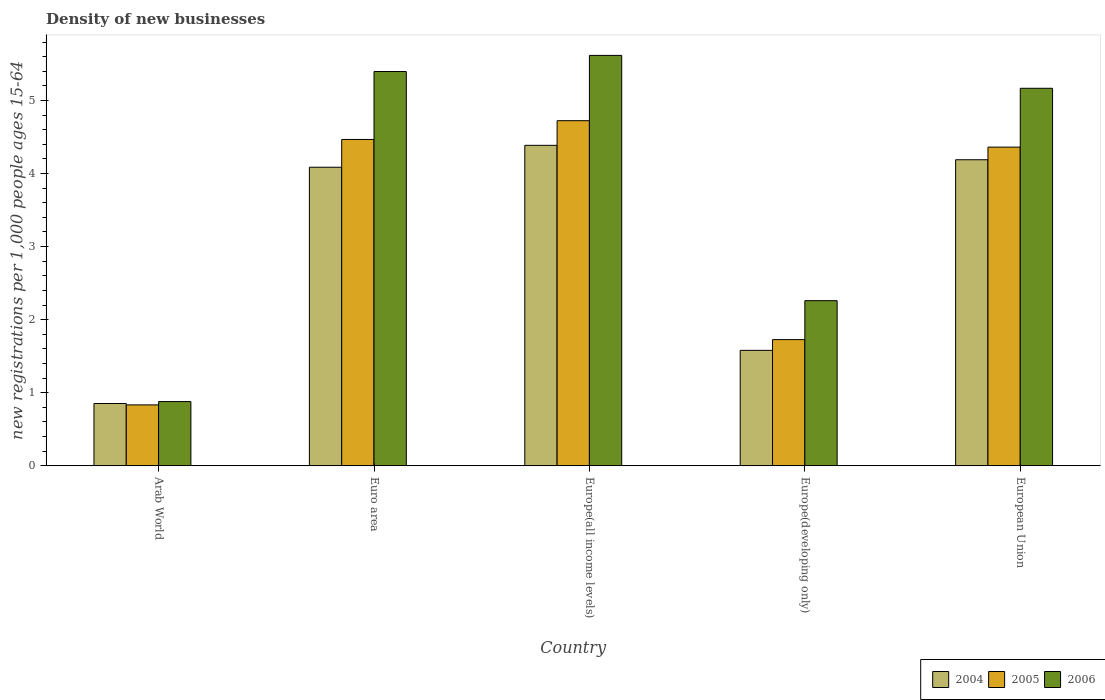How many different coloured bars are there?
Give a very brief answer. 3. Are the number of bars per tick equal to the number of legend labels?
Keep it short and to the point. Yes. How many bars are there on the 3rd tick from the right?
Keep it short and to the point. 3. What is the label of the 4th group of bars from the left?
Make the answer very short. Europe(developing only). In how many cases, is the number of bars for a given country not equal to the number of legend labels?
Offer a very short reply. 0. What is the number of new registrations in 2004 in Europe(developing only)?
Provide a succinct answer. 1.58. Across all countries, what is the maximum number of new registrations in 2006?
Keep it short and to the point. 5.62. Across all countries, what is the minimum number of new registrations in 2005?
Provide a succinct answer. 0.83. In which country was the number of new registrations in 2004 maximum?
Your answer should be very brief. Europe(all income levels). In which country was the number of new registrations in 2004 minimum?
Your answer should be compact. Arab World. What is the total number of new registrations in 2005 in the graph?
Give a very brief answer. 16.11. What is the difference between the number of new registrations in 2005 in Europe(all income levels) and that in Europe(developing only)?
Provide a succinct answer. 3. What is the difference between the number of new registrations in 2005 in Arab World and the number of new registrations in 2004 in Euro area?
Make the answer very short. -3.25. What is the average number of new registrations in 2004 per country?
Offer a terse response. 3.02. What is the difference between the number of new registrations of/in 2006 and number of new registrations of/in 2005 in European Union?
Your response must be concise. 0.81. What is the ratio of the number of new registrations in 2004 in Arab World to that in Europe(all income levels)?
Your response must be concise. 0.19. Is the difference between the number of new registrations in 2006 in Arab World and European Union greater than the difference between the number of new registrations in 2005 in Arab World and European Union?
Give a very brief answer. No. What is the difference between the highest and the second highest number of new registrations in 2006?
Your answer should be very brief. -0.22. What is the difference between the highest and the lowest number of new registrations in 2004?
Give a very brief answer. 3.53. Is the sum of the number of new registrations in 2005 in Arab World and Euro area greater than the maximum number of new registrations in 2006 across all countries?
Your answer should be compact. No. What does the 3rd bar from the right in Euro area represents?
Provide a short and direct response. 2004. Is it the case that in every country, the sum of the number of new registrations in 2004 and number of new registrations in 2005 is greater than the number of new registrations in 2006?
Provide a succinct answer. Yes. How many countries are there in the graph?
Offer a very short reply. 5. What is the difference between two consecutive major ticks on the Y-axis?
Provide a succinct answer. 1. Are the values on the major ticks of Y-axis written in scientific E-notation?
Provide a short and direct response. No. Does the graph contain grids?
Give a very brief answer. No. How many legend labels are there?
Your response must be concise. 3. What is the title of the graph?
Give a very brief answer. Density of new businesses. What is the label or title of the X-axis?
Your answer should be very brief. Country. What is the label or title of the Y-axis?
Ensure brevity in your answer.  New registrations per 1,0 people ages 15-64. What is the new registrations per 1,000 people ages 15-64 of 2004 in Arab World?
Make the answer very short. 0.85. What is the new registrations per 1,000 people ages 15-64 of 2005 in Arab World?
Your response must be concise. 0.83. What is the new registrations per 1,000 people ages 15-64 in 2006 in Arab World?
Offer a terse response. 0.88. What is the new registrations per 1,000 people ages 15-64 of 2004 in Euro area?
Give a very brief answer. 4.09. What is the new registrations per 1,000 people ages 15-64 in 2005 in Euro area?
Make the answer very short. 4.47. What is the new registrations per 1,000 people ages 15-64 in 2006 in Euro area?
Make the answer very short. 5.4. What is the new registrations per 1,000 people ages 15-64 in 2004 in Europe(all income levels)?
Provide a short and direct response. 4.39. What is the new registrations per 1,000 people ages 15-64 of 2005 in Europe(all income levels)?
Offer a terse response. 4.72. What is the new registrations per 1,000 people ages 15-64 in 2006 in Europe(all income levels)?
Your response must be concise. 5.62. What is the new registrations per 1,000 people ages 15-64 in 2004 in Europe(developing only)?
Offer a terse response. 1.58. What is the new registrations per 1,000 people ages 15-64 of 2005 in Europe(developing only)?
Keep it short and to the point. 1.73. What is the new registrations per 1,000 people ages 15-64 of 2006 in Europe(developing only)?
Keep it short and to the point. 2.26. What is the new registrations per 1,000 people ages 15-64 in 2004 in European Union?
Your answer should be very brief. 4.19. What is the new registrations per 1,000 people ages 15-64 of 2005 in European Union?
Give a very brief answer. 4.36. What is the new registrations per 1,000 people ages 15-64 of 2006 in European Union?
Offer a very short reply. 5.17. Across all countries, what is the maximum new registrations per 1,000 people ages 15-64 of 2004?
Give a very brief answer. 4.39. Across all countries, what is the maximum new registrations per 1,000 people ages 15-64 of 2005?
Give a very brief answer. 4.72. Across all countries, what is the maximum new registrations per 1,000 people ages 15-64 in 2006?
Your response must be concise. 5.62. Across all countries, what is the minimum new registrations per 1,000 people ages 15-64 of 2004?
Offer a terse response. 0.85. Across all countries, what is the minimum new registrations per 1,000 people ages 15-64 of 2005?
Make the answer very short. 0.83. Across all countries, what is the minimum new registrations per 1,000 people ages 15-64 of 2006?
Provide a short and direct response. 0.88. What is the total new registrations per 1,000 people ages 15-64 of 2004 in the graph?
Make the answer very short. 15.09. What is the total new registrations per 1,000 people ages 15-64 of 2005 in the graph?
Keep it short and to the point. 16.11. What is the total new registrations per 1,000 people ages 15-64 in 2006 in the graph?
Offer a terse response. 19.32. What is the difference between the new registrations per 1,000 people ages 15-64 in 2004 in Arab World and that in Euro area?
Keep it short and to the point. -3.23. What is the difference between the new registrations per 1,000 people ages 15-64 in 2005 in Arab World and that in Euro area?
Provide a succinct answer. -3.63. What is the difference between the new registrations per 1,000 people ages 15-64 of 2006 in Arab World and that in Euro area?
Give a very brief answer. -4.52. What is the difference between the new registrations per 1,000 people ages 15-64 in 2004 in Arab World and that in Europe(all income levels)?
Your answer should be very brief. -3.53. What is the difference between the new registrations per 1,000 people ages 15-64 of 2005 in Arab World and that in Europe(all income levels)?
Keep it short and to the point. -3.89. What is the difference between the new registrations per 1,000 people ages 15-64 of 2006 in Arab World and that in Europe(all income levels)?
Provide a succinct answer. -4.74. What is the difference between the new registrations per 1,000 people ages 15-64 in 2004 in Arab World and that in Europe(developing only)?
Make the answer very short. -0.73. What is the difference between the new registrations per 1,000 people ages 15-64 in 2005 in Arab World and that in Europe(developing only)?
Offer a very short reply. -0.89. What is the difference between the new registrations per 1,000 people ages 15-64 of 2006 in Arab World and that in Europe(developing only)?
Give a very brief answer. -1.38. What is the difference between the new registrations per 1,000 people ages 15-64 in 2004 in Arab World and that in European Union?
Give a very brief answer. -3.34. What is the difference between the new registrations per 1,000 people ages 15-64 in 2005 in Arab World and that in European Union?
Ensure brevity in your answer.  -3.53. What is the difference between the new registrations per 1,000 people ages 15-64 in 2006 in Arab World and that in European Union?
Offer a very short reply. -4.29. What is the difference between the new registrations per 1,000 people ages 15-64 of 2004 in Euro area and that in Europe(all income levels)?
Your response must be concise. -0.3. What is the difference between the new registrations per 1,000 people ages 15-64 in 2005 in Euro area and that in Europe(all income levels)?
Keep it short and to the point. -0.26. What is the difference between the new registrations per 1,000 people ages 15-64 of 2006 in Euro area and that in Europe(all income levels)?
Provide a succinct answer. -0.22. What is the difference between the new registrations per 1,000 people ages 15-64 in 2004 in Euro area and that in Europe(developing only)?
Offer a very short reply. 2.51. What is the difference between the new registrations per 1,000 people ages 15-64 in 2005 in Euro area and that in Europe(developing only)?
Your response must be concise. 2.74. What is the difference between the new registrations per 1,000 people ages 15-64 of 2006 in Euro area and that in Europe(developing only)?
Keep it short and to the point. 3.14. What is the difference between the new registrations per 1,000 people ages 15-64 of 2004 in Euro area and that in European Union?
Keep it short and to the point. -0.1. What is the difference between the new registrations per 1,000 people ages 15-64 in 2005 in Euro area and that in European Union?
Your answer should be very brief. 0.1. What is the difference between the new registrations per 1,000 people ages 15-64 in 2006 in Euro area and that in European Union?
Your answer should be compact. 0.23. What is the difference between the new registrations per 1,000 people ages 15-64 in 2004 in Europe(all income levels) and that in Europe(developing only)?
Provide a short and direct response. 2.81. What is the difference between the new registrations per 1,000 people ages 15-64 in 2005 in Europe(all income levels) and that in Europe(developing only)?
Offer a terse response. 3. What is the difference between the new registrations per 1,000 people ages 15-64 in 2006 in Europe(all income levels) and that in Europe(developing only)?
Provide a short and direct response. 3.36. What is the difference between the new registrations per 1,000 people ages 15-64 in 2004 in Europe(all income levels) and that in European Union?
Offer a very short reply. 0.2. What is the difference between the new registrations per 1,000 people ages 15-64 of 2005 in Europe(all income levels) and that in European Union?
Offer a very short reply. 0.36. What is the difference between the new registrations per 1,000 people ages 15-64 of 2006 in Europe(all income levels) and that in European Union?
Your response must be concise. 0.45. What is the difference between the new registrations per 1,000 people ages 15-64 in 2004 in Europe(developing only) and that in European Union?
Give a very brief answer. -2.61. What is the difference between the new registrations per 1,000 people ages 15-64 of 2005 in Europe(developing only) and that in European Union?
Offer a very short reply. -2.64. What is the difference between the new registrations per 1,000 people ages 15-64 of 2006 in Europe(developing only) and that in European Union?
Ensure brevity in your answer.  -2.91. What is the difference between the new registrations per 1,000 people ages 15-64 of 2004 in Arab World and the new registrations per 1,000 people ages 15-64 of 2005 in Euro area?
Offer a terse response. -3.61. What is the difference between the new registrations per 1,000 people ages 15-64 in 2004 in Arab World and the new registrations per 1,000 people ages 15-64 in 2006 in Euro area?
Your answer should be compact. -4.54. What is the difference between the new registrations per 1,000 people ages 15-64 of 2005 in Arab World and the new registrations per 1,000 people ages 15-64 of 2006 in Euro area?
Provide a short and direct response. -4.56. What is the difference between the new registrations per 1,000 people ages 15-64 in 2004 in Arab World and the new registrations per 1,000 people ages 15-64 in 2005 in Europe(all income levels)?
Offer a very short reply. -3.87. What is the difference between the new registrations per 1,000 people ages 15-64 of 2004 in Arab World and the new registrations per 1,000 people ages 15-64 of 2006 in Europe(all income levels)?
Keep it short and to the point. -4.77. What is the difference between the new registrations per 1,000 people ages 15-64 in 2005 in Arab World and the new registrations per 1,000 people ages 15-64 in 2006 in Europe(all income levels)?
Make the answer very short. -4.79. What is the difference between the new registrations per 1,000 people ages 15-64 of 2004 in Arab World and the new registrations per 1,000 people ages 15-64 of 2005 in Europe(developing only)?
Provide a succinct answer. -0.87. What is the difference between the new registrations per 1,000 people ages 15-64 in 2004 in Arab World and the new registrations per 1,000 people ages 15-64 in 2006 in Europe(developing only)?
Make the answer very short. -1.41. What is the difference between the new registrations per 1,000 people ages 15-64 of 2005 in Arab World and the new registrations per 1,000 people ages 15-64 of 2006 in Europe(developing only)?
Offer a very short reply. -1.43. What is the difference between the new registrations per 1,000 people ages 15-64 in 2004 in Arab World and the new registrations per 1,000 people ages 15-64 in 2005 in European Union?
Your response must be concise. -3.51. What is the difference between the new registrations per 1,000 people ages 15-64 in 2004 in Arab World and the new registrations per 1,000 people ages 15-64 in 2006 in European Union?
Your response must be concise. -4.32. What is the difference between the new registrations per 1,000 people ages 15-64 of 2005 in Arab World and the new registrations per 1,000 people ages 15-64 of 2006 in European Union?
Offer a terse response. -4.33. What is the difference between the new registrations per 1,000 people ages 15-64 in 2004 in Euro area and the new registrations per 1,000 people ages 15-64 in 2005 in Europe(all income levels)?
Give a very brief answer. -0.64. What is the difference between the new registrations per 1,000 people ages 15-64 of 2004 in Euro area and the new registrations per 1,000 people ages 15-64 of 2006 in Europe(all income levels)?
Keep it short and to the point. -1.53. What is the difference between the new registrations per 1,000 people ages 15-64 of 2005 in Euro area and the new registrations per 1,000 people ages 15-64 of 2006 in Europe(all income levels)?
Your answer should be compact. -1.15. What is the difference between the new registrations per 1,000 people ages 15-64 of 2004 in Euro area and the new registrations per 1,000 people ages 15-64 of 2005 in Europe(developing only)?
Your answer should be compact. 2.36. What is the difference between the new registrations per 1,000 people ages 15-64 in 2004 in Euro area and the new registrations per 1,000 people ages 15-64 in 2006 in Europe(developing only)?
Provide a succinct answer. 1.83. What is the difference between the new registrations per 1,000 people ages 15-64 in 2005 in Euro area and the new registrations per 1,000 people ages 15-64 in 2006 in Europe(developing only)?
Make the answer very short. 2.21. What is the difference between the new registrations per 1,000 people ages 15-64 of 2004 in Euro area and the new registrations per 1,000 people ages 15-64 of 2005 in European Union?
Offer a very short reply. -0.28. What is the difference between the new registrations per 1,000 people ages 15-64 of 2004 in Euro area and the new registrations per 1,000 people ages 15-64 of 2006 in European Union?
Provide a short and direct response. -1.08. What is the difference between the new registrations per 1,000 people ages 15-64 in 2005 in Euro area and the new registrations per 1,000 people ages 15-64 in 2006 in European Union?
Keep it short and to the point. -0.7. What is the difference between the new registrations per 1,000 people ages 15-64 of 2004 in Europe(all income levels) and the new registrations per 1,000 people ages 15-64 of 2005 in Europe(developing only)?
Your answer should be very brief. 2.66. What is the difference between the new registrations per 1,000 people ages 15-64 in 2004 in Europe(all income levels) and the new registrations per 1,000 people ages 15-64 in 2006 in Europe(developing only)?
Provide a succinct answer. 2.13. What is the difference between the new registrations per 1,000 people ages 15-64 in 2005 in Europe(all income levels) and the new registrations per 1,000 people ages 15-64 in 2006 in Europe(developing only)?
Keep it short and to the point. 2.46. What is the difference between the new registrations per 1,000 people ages 15-64 of 2004 in Europe(all income levels) and the new registrations per 1,000 people ages 15-64 of 2005 in European Union?
Keep it short and to the point. 0.02. What is the difference between the new registrations per 1,000 people ages 15-64 of 2004 in Europe(all income levels) and the new registrations per 1,000 people ages 15-64 of 2006 in European Union?
Ensure brevity in your answer.  -0.78. What is the difference between the new registrations per 1,000 people ages 15-64 of 2005 in Europe(all income levels) and the new registrations per 1,000 people ages 15-64 of 2006 in European Union?
Keep it short and to the point. -0.44. What is the difference between the new registrations per 1,000 people ages 15-64 in 2004 in Europe(developing only) and the new registrations per 1,000 people ages 15-64 in 2005 in European Union?
Offer a very short reply. -2.78. What is the difference between the new registrations per 1,000 people ages 15-64 of 2004 in Europe(developing only) and the new registrations per 1,000 people ages 15-64 of 2006 in European Union?
Give a very brief answer. -3.59. What is the difference between the new registrations per 1,000 people ages 15-64 in 2005 in Europe(developing only) and the new registrations per 1,000 people ages 15-64 in 2006 in European Union?
Your response must be concise. -3.44. What is the average new registrations per 1,000 people ages 15-64 of 2004 per country?
Provide a succinct answer. 3.02. What is the average new registrations per 1,000 people ages 15-64 in 2005 per country?
Your response must be concise. 3.22. What is the average new registrations per 1,000 people ages 15-64 in 2006 per country?
Offer a terse response. 3.86. What is the difference between the new registrations per 1,000 people ages 15-64 in 2004 and new registrations per 1,000 people ages 15-64 in 2005 in Arab World?
Provide a succinct answer. 0.02. What is the difference between the new registrations per 1,000 people ages 15-64 of 2004 and new registrations per 1,000 people ages 15-64 of 2006 in Arab World?
Offer a terse response. -0.03. What is the difference between the new registrations per 1,000 people ages 15-64 in 2005 and new registrations per 1,000 people ages 15-64 in 2006 in Arab World?
Ensure brevity in your answer.  -0.05. What is the difference between the new registrations per 1,000 people ages 15-64 of 2004 and new registrations per 1,000 people ages 15-64 of 2005 in Euro area?
Provide a short and direct response. -0.38. What is the difference between the new registrations per 1,000 people ages 15-64 of 2004 and new registrations per 1,000 people ages 15-64 of 2006 in Euro area?
Provide a short and direct response. -1.31. What is the difference between the new registrations per 1,000 people ages 15-64 in 2005 and new registrations per 1,000 people ages 15-64 in 2006 in Euro area?
Your answer should be very brief. -0.93. What is the difference between the new registrations per 1,000 people ages 15-64 in 2004 and new registrations per 1,000 people ages 15-64 in 2005 in Europe(all income levels)?
Your response must be concise. -0.34. What is the difference between the new registrations per 1,000 people ages 15-64 in 2004 and new registrations per 1,000 people ages 15-64 in 2006 in Europe(all income levels)?
Your answer should be compact. -1.23. What is the difference between the new registrations per 1,000 people ages 15-64 of 2005 and new registrations per 1,000 people ages 15-64 of 2006 in Europe(all income levels)?
Your response must be concise. -0.89. What is the difference between the new registrations per 1,000 people ages 15-64 of 2004 and new registrations per 1,000 people ages 15-64 of 2005 in Europe(developing only)?
Offer a very short reply. -0.15. What is the difference between the new registrations per 1,000 people ages 15-64 of 2004 and new registrations per 1,000 people ages 15-64 of 2006 in Europe(developing only)?
Your answer should be very brief. -0.68. What is the difference between the new registrations per 1,000 people ages 15-64 of 2005 and new registrations per 1,000 people ages 15-64 of 2006 in Europe(developing only)?
Keep it short and to the point. -0.53. What is the difference between the new registrations per 1,000 people ages 15-64 of 2004 and new registrations per 1,000 people ages 15-64 of 2005 in European Union?
Provide a succinct answer. -0.17. What is the difference between the new registrations per 1,000 people ages 15-64 in 2004 and new registrations per 1,000 people ages 15-64 in 2006 in European Union?
Ensure brevity in your answer.  -0.98. What is the difference between the new registrations per 1,000 people ages 15-64 in 2005 and new registrations per 1,000 people ages 15-64 in 2006 in European Union?
Provide a short and direct response. -0.81. What is the ratio of the new registrations per 1,000 people ages 15-64 in 2004 in Arab World to that in Euro area?
Offer a terse response. 0.21. What is the ratio of the new registrations per 1,000 people ages 15-64 of 2005 in Arab World to that in Euro area?
Keep it short and to the point. 0.19. What is the ratio of the new registrations per 1,000 people ages 15-64 in 2006 in Arab World to that in Euro area?
Your answer should be compact. 0.16. What is the ratio of the new registrations per 1,000 people ages 15-64 of 2004 in Arab World to that in Europe(all income levels)?
Give a very brief answer. 0.19. What is the ratio of the new registrations per 1,000 people ages 15-64 in 2005 in Arab World to that in Europe(all income levels)?
Your answer should be compact. 0.18. What is the ratio of the new registrations per 1,000 people ages 15-64 of 2006 in Arab World to that in Europe(all income levels)?
Make the answer very short. 0.16. What is the ratio of the new registrations per 1,000 people ages 15-64 of 2004 in Arab World to that in Europe(developing only)?
Offer a terse response. 0.54. What is the ratio of the new registrations per 1,000 people ages 15-64 in 2005 in Arab World to that in Europe(developing only)?
Provide a succinct answer. 0.48. What is the ratio of the new registrations per 1,000 people ages 15-64 in 2006 in Arab World to that in Europe(developing only)?
Ensure brevity in your answer.  0.39. What is the ratio of the new registrations per 1,000 people ages 15-64 in 2004 in Arab World to that in European Union?
Offer a terse response. 0.2. What is the ratio of the new registrations per 1,000 people ages 15-64 in 2005 in Arab World to that in European Union?
Your answer should be very brief. 0.19. What is the ratio of the new registrations per 1,000 people ages 15-64 of 2006 in Arab World to that in European Union?
Make the answer very short. 0.17. What is the ratio of the new registrations per 1,000 people ages 15-64 in 2004 in Euro area to that in Europe(all income levels)?
Keep it short and to the point. 0.93. What is the ratio of the new registrations per 1,000 people ages 15-64 of 2005 in Euro area to that in Europe(all income levels)?
Keep it short and to the point. 0.95. What is the ratio of the new registrations per 1,000 people ages 15-64 of 2006 in Euro area to that in Europe(all income levels)?
Your response must be concise. 0.96. What is the ratio of the new registrations per 1,000 people ages 15-64 of 2004 in Euro area to that in Europe(developing only)?
Give a very brief answer. 2.59. What is the ratio of the new registrations per 1,000 people ages 15-64 in 2005 in Euro area to that in Europe(developing only)?
Your answer should be very brief. 2.59. What is the ratio of the new registrations per 1,000 people ages 15-64 in 2006 in Euro area to that in Europe(developing only)?
Make the answer very short. 2.39. What is the ratio of the new registrations per 1,000 people ages 15-64 of 2004 in Euro area to that in European Union?
Your answer should be very brief. 0.98. What is the ratio of the new registrations per 1,000 people ages 15-64 of 2005 in Euro area to that in European Union?
Provide a short and direct response. 1.02. What is the ratio of the new registrations per 1,000 people ages 15-64 in 2006 in Euro area to that in European Union?
Provide a short and direct response. 1.04. What is the ratio of the new registrations per 1,000 people ages 15-64 of 2004 in Europe(all income levels) to that in Europe(developing only)?
Your response must be concise. 2.78. What is the ratio of the new registrations per 1,000 people ages 15-64 of 2005 in Europe(all income levels) to that in Europe(developing only)?
Make the answer very short. 2.74. What is the ratio of the new registrations per 1,000 people ages 15-64 of 2006 in Europe(all income levels) to that in Europe(developing only)?
Your answer should be compact. 2.49. What is the ratio of the new registrations per 1,000 people ages 15-64 in 2004 in Europe(all income levels) to that in European Union?
Provide a short and direct response. 1.05. What is the ratio of the new registrations per 1,000 people ages 15-64 of 2005 in Europe(all income levels) to that in European Union?
Offer a very short reply. 1.08. What is the ratio of the new registrations per 1,000 people ages 15-64 in 2006 in Europe(all income levels) to that in European Union?
Make the answer very short. 1.09. What is the ratio of the new registrations per 1,000 people ages 15-64 in 2004 in Europe(developing only) to that in European Union?
Offer a terse response. 0.38. What is the ratio of the new registrations per 1,000 people ages 15-64 of 2005 in Europe(developing only) to that in European Union?
Offer a terse response. 0.4. What is the ratio of the new registrations per 1,000 people ages 15-64 in 2006 in Europe(developing only) to that in European Union?
Your answer should be very brief. 0.44. What is the difference between the highest and the second highest new registrations per 1,000 people ages 15-64 of 2004?
Provide a succinct answer. 0.2. What is the difference between the highest and the second highest new registrations per 1,000 people ages 15-64 of 2005?
Keep it short and to the point. 0.26. What is the difference between the highest and the second highest new registrations per 1,000 people ages 15-64 of 2006?
Your response must be concise. 0.22. What is the difference between the highest and the lowest new registrations per 1,000 people ages 15-64 of 2004?
Your answer should be compact. 3.53. What is the difference between the highest and the lowest new registrations per 1,000 people ages 15-64 in 2005?
Provide a short and direct response. 3.89. What is the difference between the highest and the lowest new registrations per 1,000 people ages 15-64 of 2006?
Ensure brevity in your answer.  4.74. 